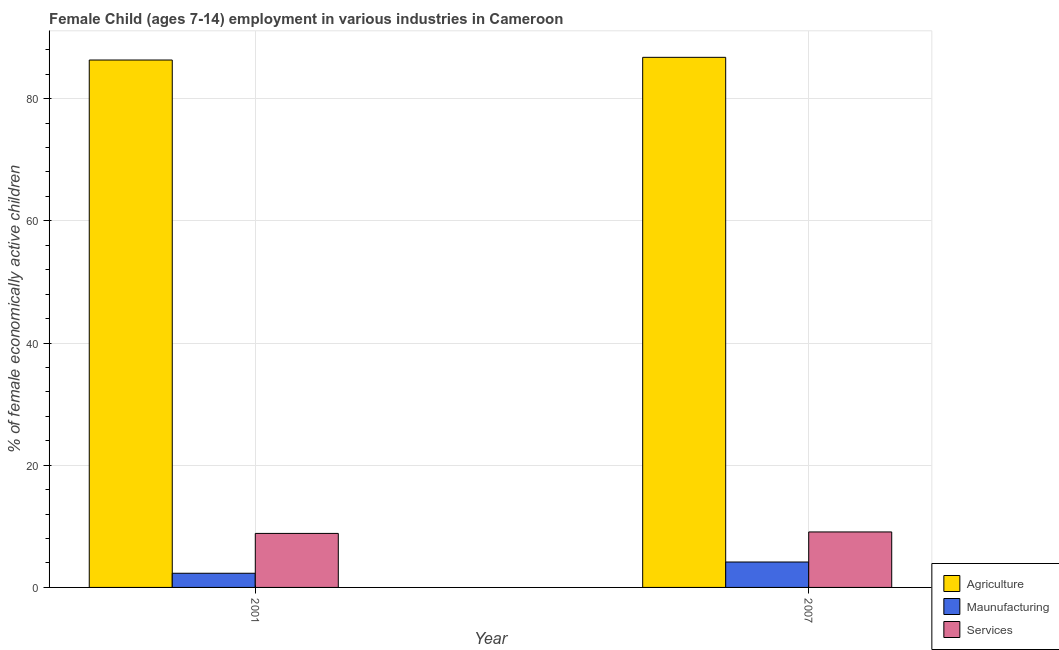Are the number of bars per tick equal to the number of legend labels?
Your answer should be very brief. Yes. Are the number of bars on each tick of the X-axis equal?
Ensure brevity in your answer.  Yes. What is the percentage of economically active children in manufacturing in 2001?
Your response must be concise. 2.32. Across all years, what is the maximum percentage of economically active children in services?
Make the answer very short. 9.08. Across all years, what is the minimum percentage of economically active children in agriculture?
Provide a succinct answer. 86.32. In which year was the percentage of economically active children in services minimum?
Keep it short and to the point. 2001. What is the total percentage of economically active children in services in the graph?
Make the answer very short. 17.92. What is the difference between the percentage of economically active children in manufacturing in 2001 and that in 2007?
Offer a very short reply. -1.84. What is the difference between the percentage of economically active children in agriculture in 2007 and the percentage of economically active children in manufacturing in 2001?
Give a very brief answer. 0.44. What is the average percentage of economically active children in agriculture per year?
Ensure brevity in your answer.  86.54. In the year 2001, what is the difference between the percentage of economically active children in services and percentage of economically active children in agriculture?
Provide a succinct answer. 0. In how many years, is the percentage of economically active children in agriculture greater than 56 %?
Your answer should be very brief. 2. What is the ratio of the percentage of economically active children in services in 2001 to that in 2007?
Make the answer very short. 0.97. What does the 3rd bar from the left in 2007 represents?
Offer a very short reply. Services. What does the 2nd bar from the right in 2007 represents?
Offer a very short reply. Maunufacturing. Is it the case that in every year, the sum of the percentage of economically active children in agriculture and percentage of economically active children in manufacturing is greater than the percentage of economically active children in services?
Your answer should be very brief. Yes. How many bars are there?
Keep it short and to the point. 6. Are all the bars in the graph horizontal?
Make the answer very short. No. Are the values on the major ticks of Y-axis written in scientific E-notation?
Make the answer very short. No. Does the graph contain any zero values?
Keep it short and to the point. No. Does the graph contain grids?
Make the answer very short. Yes. How many legend labels are there?
Give a very brief answer. 3. How are the legend labels stacked?
Your answer should be very brief. Vertical. What is the title of the graph?
Ensure brevity in your answer.  Female Child (ages 7-14) employment in various industries in Cameroon. What is the label or title of the X-axis?
Offer a terse response. Year. What is the label or title of the Y-axis?
Offer a terse response. % of female economically active children. What is the % of female economically active children in Agriculture in 2001?
Your answer should be very brief. 86.32. What is the % of female economically active children of Maunufacturing in 2001?
Provide a succinct answer. 2.32. What is the % of female economically active children in Services in 2001?
Provide a succinct answer. 8.84. What is the % of female economically active children in Agriculture in 2007?
Ensure brevity in your answer.  86.76. What is the % of female economically active children of Maunufacturing in 2007?
Ensure brevity in your answer.  4.16. What is the % of female economically active children of Services in 2007?
Offer a very short reply. 9.08. Across all years, what is the maximum % of female economically active children in Agriculture?
Your answer should be very brief. 86.76. Across all years, what is the maximum % of female economically active children of Maunufacturing?
Keep it short and to the point. 4.16. Across all years, what is the maximum % of female economically active children in Services?
Offer a terse response. 9.08. Across all years, what is the minimum % of female economically active children of Agriculture?
Give a very brief answer. 86.32. Across all years, what is the minimum % of female economically active children in Maunufacturing?
Provide a succinct answer. 2.32. Across all years, what is the minimum % of female economically active children in Services?
Keep it short and to the point. 8.84. What is the total % of female economically active children in Agriculture in the graph?
Make the answer very short. 173.08. What is the total % of female economically active children of Maunufacturing in the graph?
Offer a very short reply. 6.48. What is the total % of female economically active children of Services in the graph?
Offer a very short reply. 17.92. What is the difference between the % of female economically active children of Agriculture in 2001 and that in 2007?
Offer a terse response. -0.44. What is the difference between the % of female economically active children in Maunufacturing in 2001 and that in 2007?
Ensure brevity in your answer.  -1.84. What is the difference between the % of female economically active children of Services in 2001 and that in 2007?
Offer a terse response. -0.24. What is the difference between the % of female economically active children of Agriculture in 2001 and the % of female economically active children of Maunufacturing in 2007?
Your answer should be very brief. 82.16. What is the difference between the % of female economically active children of Agriculture in 2001 and the % of female economically active children of Services in 2007?
Give a very brief answer. 77.24. What is the difference between the % of female economically active children in Maunufacturing in 2001 and the % of female economically active children in Services in 2007?
Offer a terse response. -6.76. What is the average % of female economically active children of Agriculture per year?
Your response must be concise. 86.54. What is the average % of female economically active children in Maunufacturing per year?
Give a very brief answer. 3.24. What is the average % of female economically active children in Services per year?
Your answer should be very brief. 8.96. In the year 2001, what is the difference between the % of female economically active children in Agriculture and % of female economically active children in Maunufacturing?
Your response must be concise. 84. In the year 2001, what is the difference between the % of female economically active children of Agriculture and % of female economically active children of Services?
Give a very brief answer. 77.48. In the year 2001, what is the difference between the % of female economically active children of Maunufacturing and % of female economically active children of Services?
Your response must be concise. -6.52. In the year 2007, what is the difference between the % of female economically active children of Agriculture and % of female economically active children of Maunufacturing?
Keep it short and to the point. 82.6. In the year 2007, what is the difference between the % of female economically active children of Agriculture and % of female economically active children of Services?
Provide a short and direct response. 77.68. In the year 2007, what is the difference between the % of female economically active children in Maunufacturing and % of female economically active children in Services?
Offer a terse response. -4.92. What is the ratio of the % of female economically active children of Maunufacturing in 2001 to that in 2007?
Offer a terse response. 0.56. What is the ratio of the % of female economically active children in Services in 2001 to that in 2007?
Keep it short and to the point. 0.97. What is the difference between the highest and the second highest % of female economically active children in Agriculture?
Your response must be concise. 0.44. What is the difference between the highest and the second highest % of female economically active children of Maunufacturing?
Your answer should be compact. 1.84. What is the difference between the highest and the second highest % of female economically active children of Services?
Your answer should be compact. 0.24. What is the difference between the highest and the lowest % of female economically active children in Agriculture?
Your response must be concise. 0.44. What is the difference between the highest and the lowest % of female economically active children in Maunufacturing?
Give a very brief answer. 1.84. What is the difference between the highest and the lowest % of female economically active children of Services?
Your response must be concise. 0.24. 